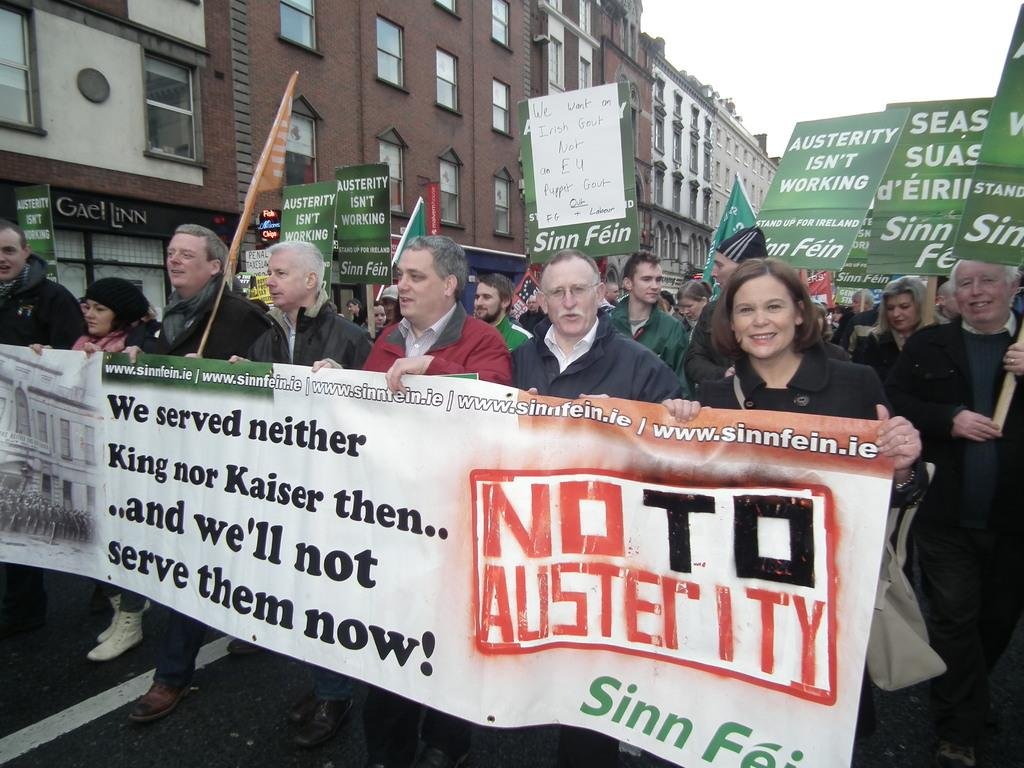What are the people in the foreground of the image holding? The people in the foreground of the image are holding a flex and posters. What type of setting is depicted in the image? The scene appears to be at stalls. What can be seen in the background of the image? There are buildings and the sky visible in the background of the image. Reasoning: Let's think step by step by following the given facts step by step to produce the conversation. We start by identifying the main subjects in the foreground, which are the people holding a flex and posters. Then, we describe the setting of the image, which is at stalls. Finally, we mention the background elements, which include buildings and the sky. Each question is designed to elicit a specific detail about the image that is known from the provided facts. Absurd Question/Answer: What shape is the quartz in the image? There is no quartz present in the image. What fact can be determined about the flex being held by the people in the image? The fact that the people are holding a flex in the image is already mentioned in the conversation, so there is no need to ask a question about it again. 